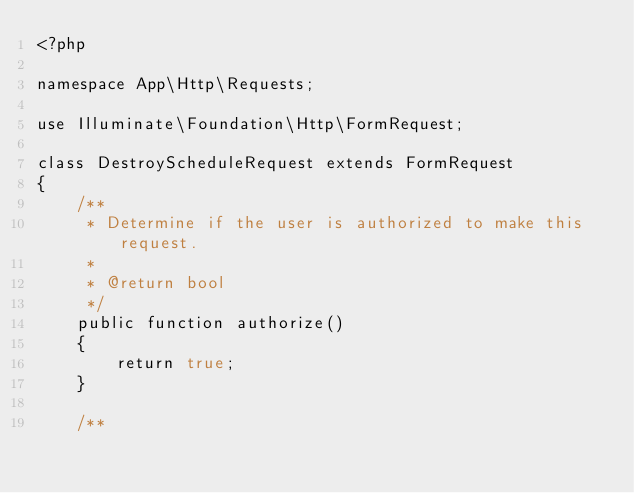Convert code to text. <code><loc_0><loc_0><loc_500><loc_500><_PHP_><?php

namespace App\Http\Requests;

use Illuminate\Foundation\Http\FormRequest;

class DestroyScheduleRequest extends FormRequest
{
    /**
     * Determine if the user is authorized to make this request.
     *
     * @return bool
     */
    public function authorize()
    {
        return true;
    }

    /**</code> 